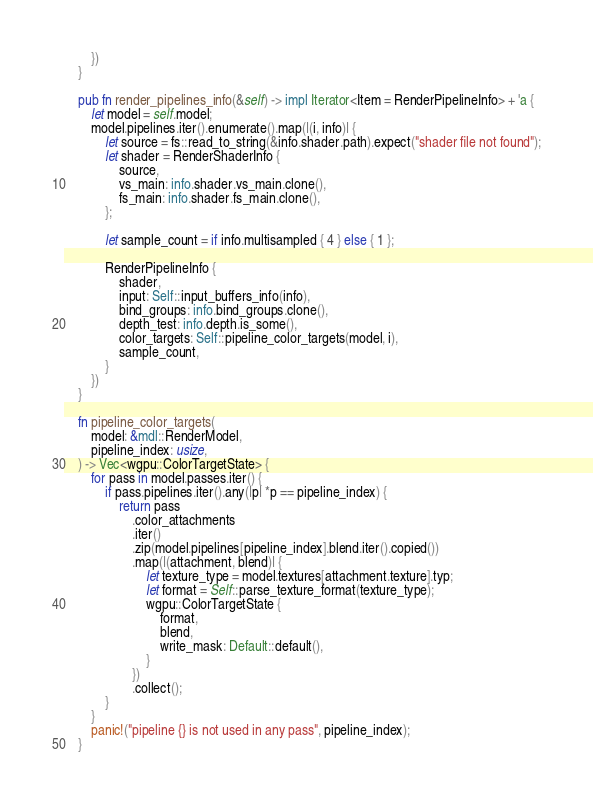Convert code to text. <code><loc_0><loc_0><loc_500><loc_500><_Rust_>        })
    }

    pub fn render_pipelines_info(&self) -> impl Iterator<Item = RenderPipelineInfo> + 'a {
        let model = self.model;
        model.pipelines.iter().enumerate().map(|(i, info)| {
            let source = fs::read_to_string(&info.shader.path).expect("shader file not found");
            let shader = RenderShaderInfo {
                source,
                vs_main: info.shader.vs_main.clone(),
                fs_main: info.shader.fs_main.clone(),
            };

            let sample_count = if info.multisampled { 4 } else { 1 };

            RenderPipelineInfo {
                shader,
                input: Self::input_buffers_info(info),
                bind_groups: info.bind_groups.clone(),
                depth_test: info.depth.is_some(),
                color_targets: Self::pipeline_color_targets(model, i),
                sample_count,
            }
        })
    }

    fn pipeline_color_targets(
        model: &mdl::RenderModel,
        pipeline_index: usize,
    ) -> Vec<wgpu::ColorTargetState> {
        for pass in model.passes.iter() {
            if pass.pipelines.iter().any(|p| *p == pipeline_index) {
                return pass
                    .color_attachments
                    .iter()
                    .zip(model.pipelines[pipeline_index].blend.iter().copied())
                    .map(|(attachment, blend)| {
                        let texture_type = model.textures[attachment.texture].typ;
                        let format = Self::parse_texture_format(texture_type);
                        wgpu::ColorTargetState {
                            format,
                            blend,
                            write_mask: Default::default(),
                        }
                    })
                    .collect();
            }
        }
        panic!("pipeline {} is not used in any pass", pipeline_index);
    }
</code> 